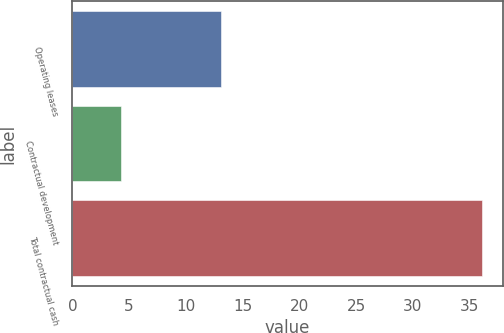<chart> <loc_0><loc_0><loc_500><loc_500><bar_chart><fcel>Operating leases<fcel>Contractual development<fcel>Total contractual cash<nl><fcel>13.1<fcel>4.3<fcel>36.1<nl></chart> 